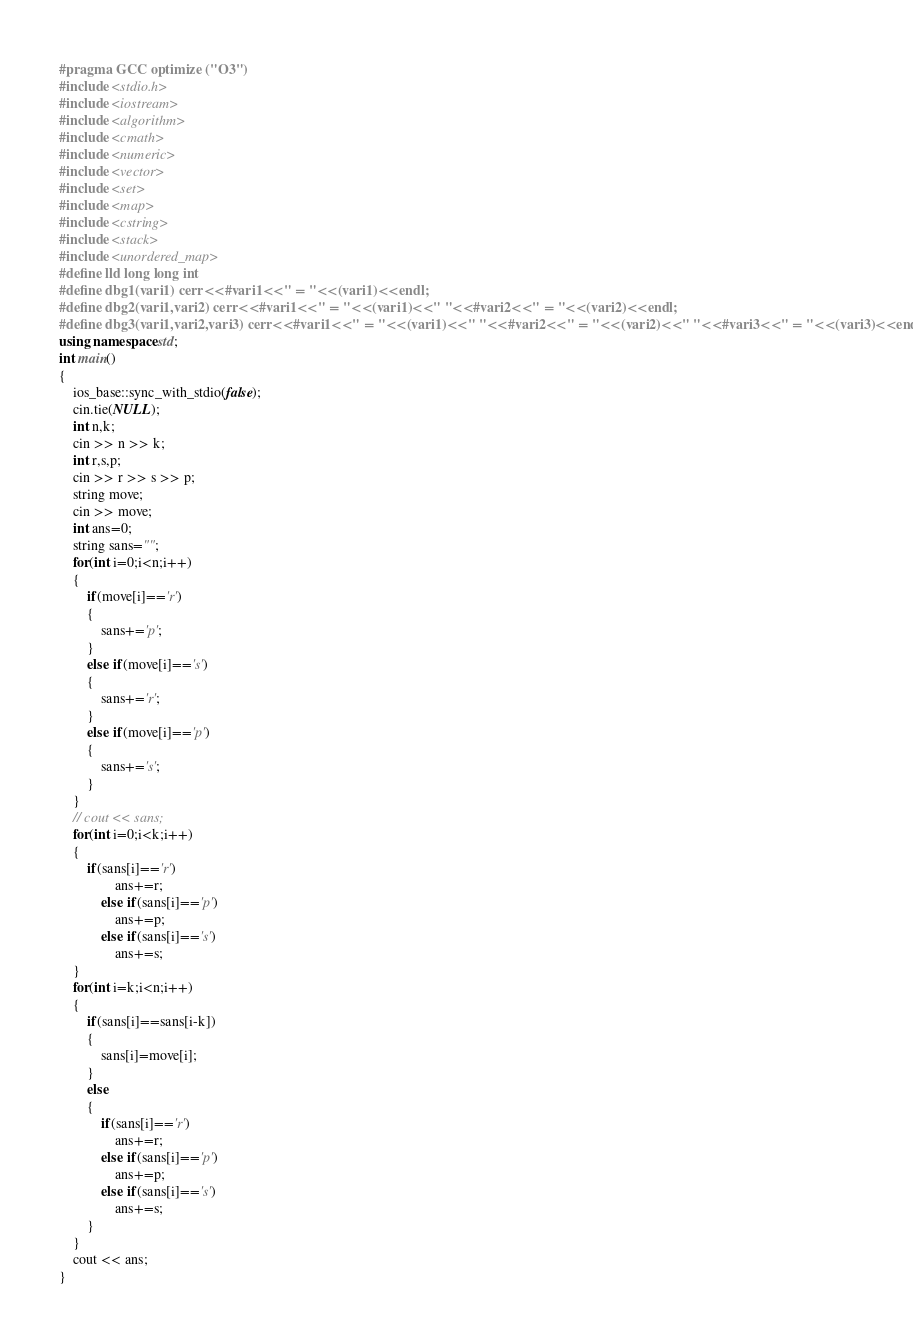<code> <loc_0><loc_0><loc_500><loc_500><_C++_>#pragma GCC optimize ("O3")
#include <stdio.h>
#include <iostream>
#include <algorithm>
#include <cmath>
#include <numeric>
#include <vector>
#include <set>
#include <map>
#include <cstring>
#include <stack>
#include <unordered_map>
#define lld long long int
#define dbg1(vari1) cerr<<#vari1<<" = "<<(vari1)<<endl;
#define dbg2(vari1,vari2) cerr<<#vari1<<" = "<<(vari1)<<" "<<#vari2<<" = "<<(vari2)<<endl;
#define dbg3(vari1,vari2,vari3) cerr<<#vari1<<" = "<<(vari1)<<" "<<#vari2<<" = "<<(vari2)<<" "<<#vari3<<" = "<<(vari3)<<endl;
using namespace std;
int main()
{
	ios_base::sync_with_stdio(false);
	cin.tie(NULL);
	int n,k;
	cin >> n >> k;
	int r,s,p;
	cin >> r >> s >> p;
	string move;
	cin >> move;
	int ans=0;
	string sans="";
	for(int i=0;i<n;i++)
	{
		if(move[i]=='r')
		{
			sans+='p';
		}
		else if(move[i]=='s')
		{
			sans+='r';
		}
		else if(move[i]=='p')
		{
			sans+='s';
		}
	}
	// cout << sans;
	for(int i=0;i<k;i++)
	{
		if(sans[i]=='r')
				ans+=r;
			else if(sans[i]=='p')
				ans+=p;
			else if(sans[i]=='s')
				ans+=s;
	}
	for(int i=k;i<n;i++)
	{
		if(sans[i]==sans[i-k])
		{
			sans[i]=move[i];
		}
		else
		{
			if(sans[i]=='r')
				ans+=r;
			else if(sans[i]=='p')
				ans+=p;
			else if(sans[i]=='s')
				ans+=s;
		}
	}
	cout << ans;
}</code> 